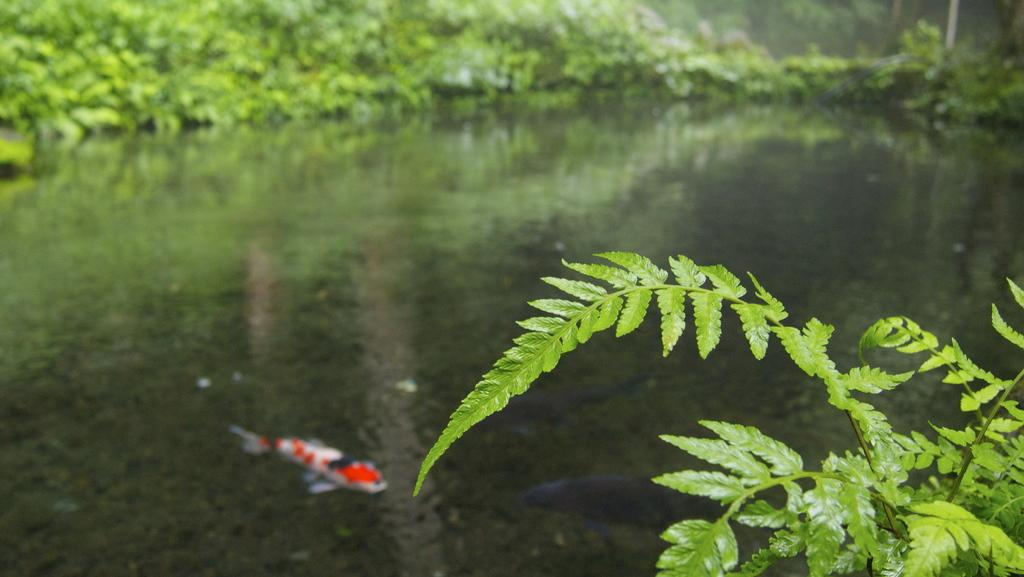What type of vegetation can be seen in the image? There are leaves visible in the image. What natural element is also present in the image? There is water visible in the image. What type of animals can be seen in the water? There are fish in the water in the image. How would you describe the background of the image? The background of the image is blurred. Can you tell me how many times the person at the wrist cried on that day? There is no person or wrist visible in the image, and therefore no such activity can be observed. 